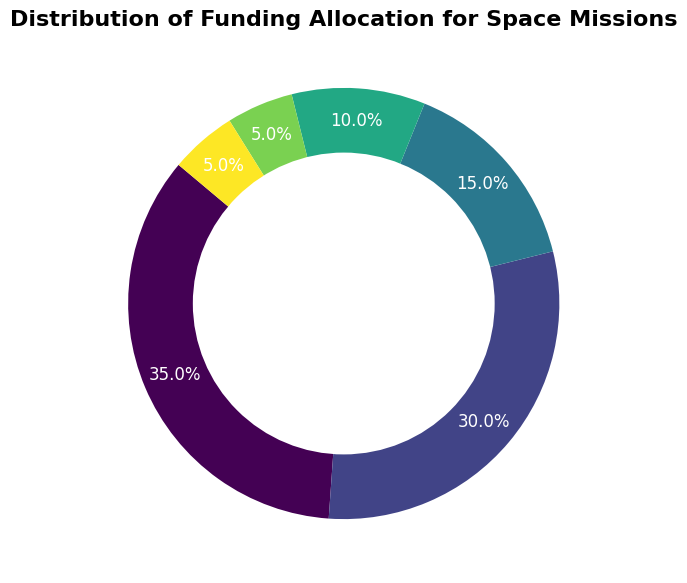What percentage of the funding is allocated to Engineering and Life Support combined? Add the percentages for Engineering (30%) and Life Support (15%) together: 30 + 15 = 45
Answer: 45% Which category receives more funding, Communication or Training? Compare the percentages: Communication has 10% while Training has 5%. Therefore, Communication receives more funding.
Answer: Communication What is the smallest category in terms of funding? From the pie chart, the smallest percentages are Training and Logistics, each receiving 5%. So, the answer is either Training or Logistics.
Answer: Training or Logistics Is the funding for Life Support closer to the funding for Engineering or the funding for Research? Life Support has 15%. Engineering has 30%, and Research has 35%. The difference between Life Support and Engineering is 30 - 15 = 15. The difference between Life Support and Research is 35 - 15 = 20. Since 15 < 20, Life Support is closer to Engineering.
Answer: Engineering What is the total percentage of funding allocated to categories other than Research and Engineering? Subtract the combined percentage of Research and Engineering from 100%: 100 - (35 + 30) = 100 - 65 = 35
Answer: 35% Which category on the pie chart has the second largest allocation of funding? The pie chart shows Research has the largest at 35%, followed by Engineering at 30%. So, Engineering is the second largest.
Answer: Engineering By how much does the percentage of funding for Research exceed the percentage for Communication? Subtract the percentage for Communication (10%) from Research (35%): 35 - 10 = 25
Answer: 25% If the funding for all categories except Research and Engineering is doubled, what will be Life Support's new percentage? Double the original percentage of Life Support (15%): 15 * 2 = 30
Answer: 30% Which category's percentage is represented by the color closest to green? The pie chart likely uses a colormap that gradually changes, starting from one hue to another. The third most significant color (after Research and Engineering) closest to green represents Life Support.
Answer: Life Support 